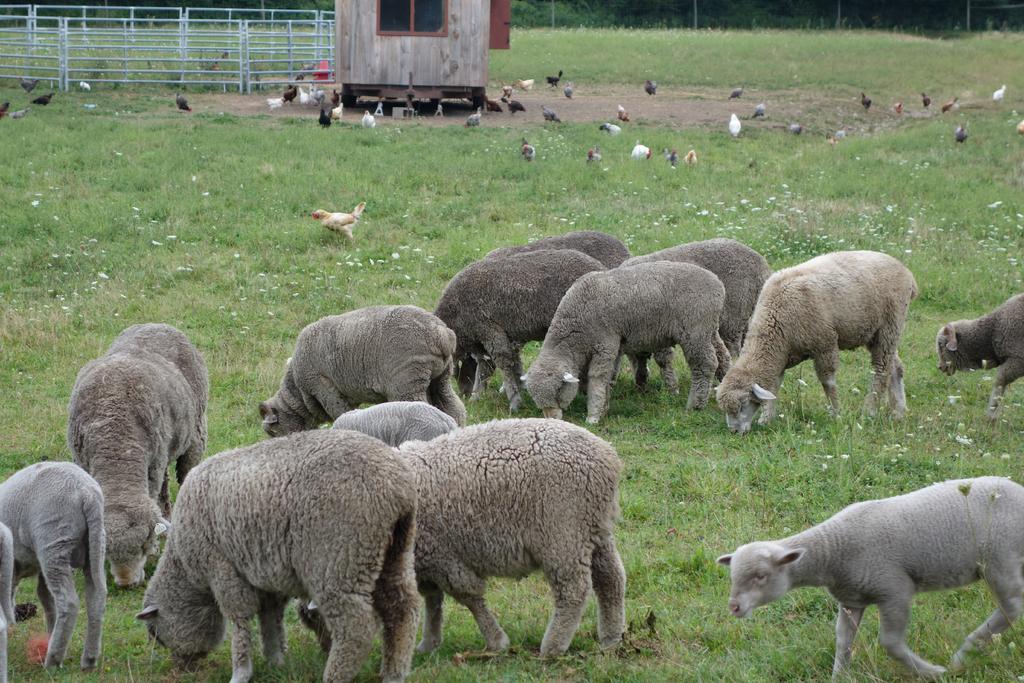Describe this image in one or two sentences. In this image there are a group of people eating the grass, beside them there are some birds, fence and block. 